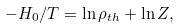<formula> <loc_0><loc_0><loc_500><loc_500>- H _ { 0 } / T = \ln \rho _ { t h } + \ln Z ,</formula> 